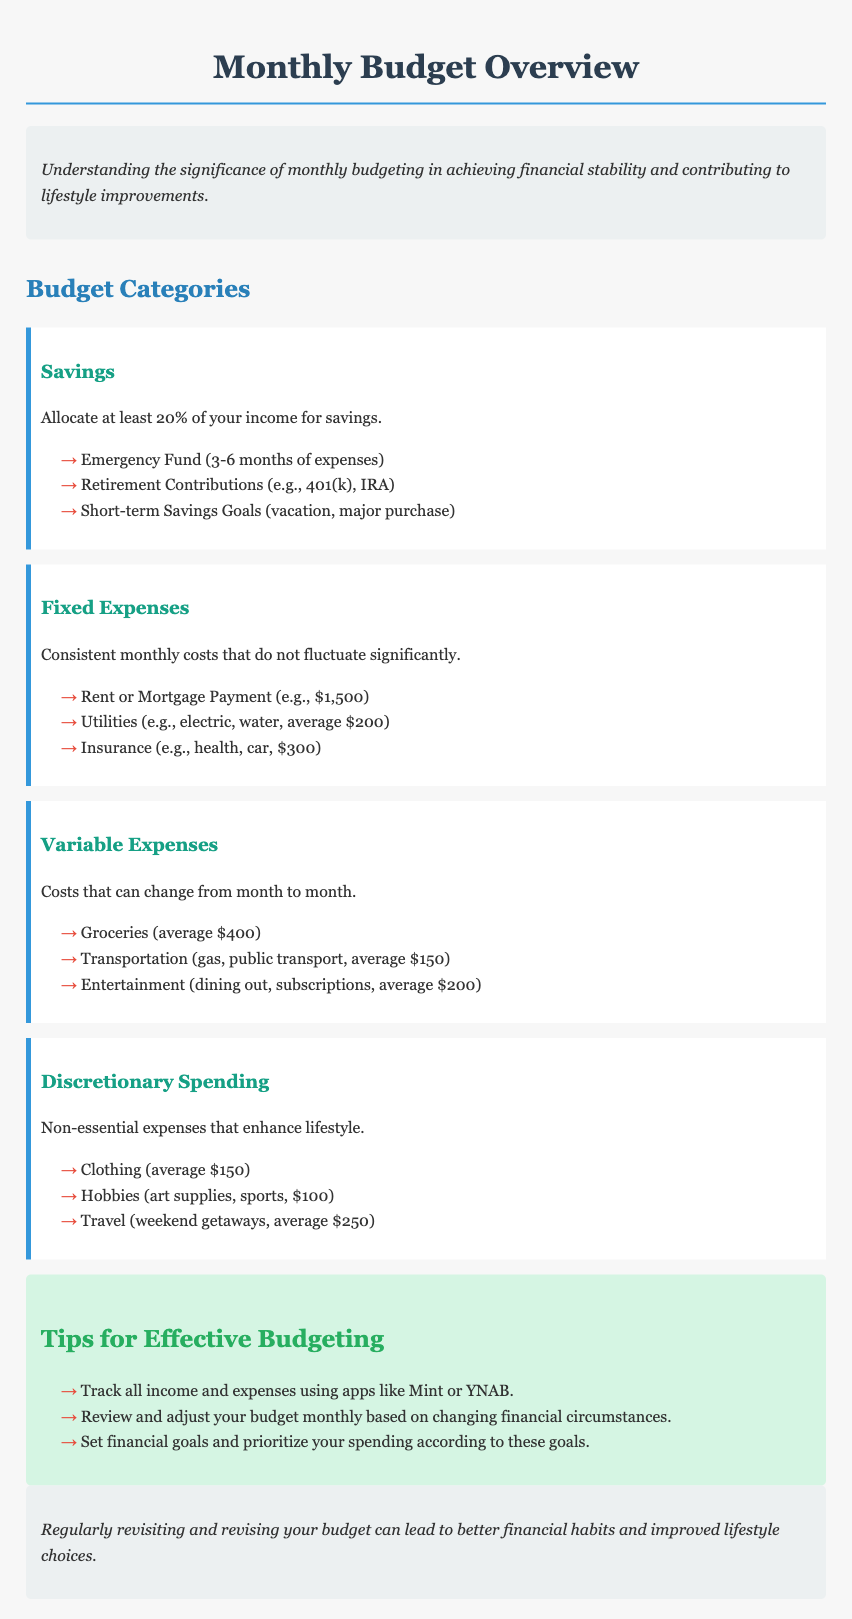What percentage of income should be allocated for savings? The document states that at least 20% of your income should be allocated for savings.
Answer: 20% What is the average cost of utilities? The average cost of utilities mentioned is $200.
Answer: $200 List one example of a short-term savings goal. The document mentions vacation as an example of a short-term savings goal.
Answer: vacation What are fixed expenses? Fixed expenses are described as consistent monthly costs that do not fluctuate significantly.
Answer: consistent monthly costs How much is the average expense for entertainment? The average expense for entertainment, as noted in the document, is $200.
Answer: $200 What is one tip for effective budgeting mentioned? One tip provided is to track all income and expenses using apps like Mint or YNAB.
Answer: track all income and expenses Why is regular revisiting of the budget important? The conclusion states that it can lead to better financial habits and improved lifestyle choices.
Answer: better financial habits What is the average clothing expense? The document lists the average clothing expense as $150.
Answer: $150 What category does emergency fund fall into? The emergency fund falls under the Savings category as specified in the document.
Answer: Savings 